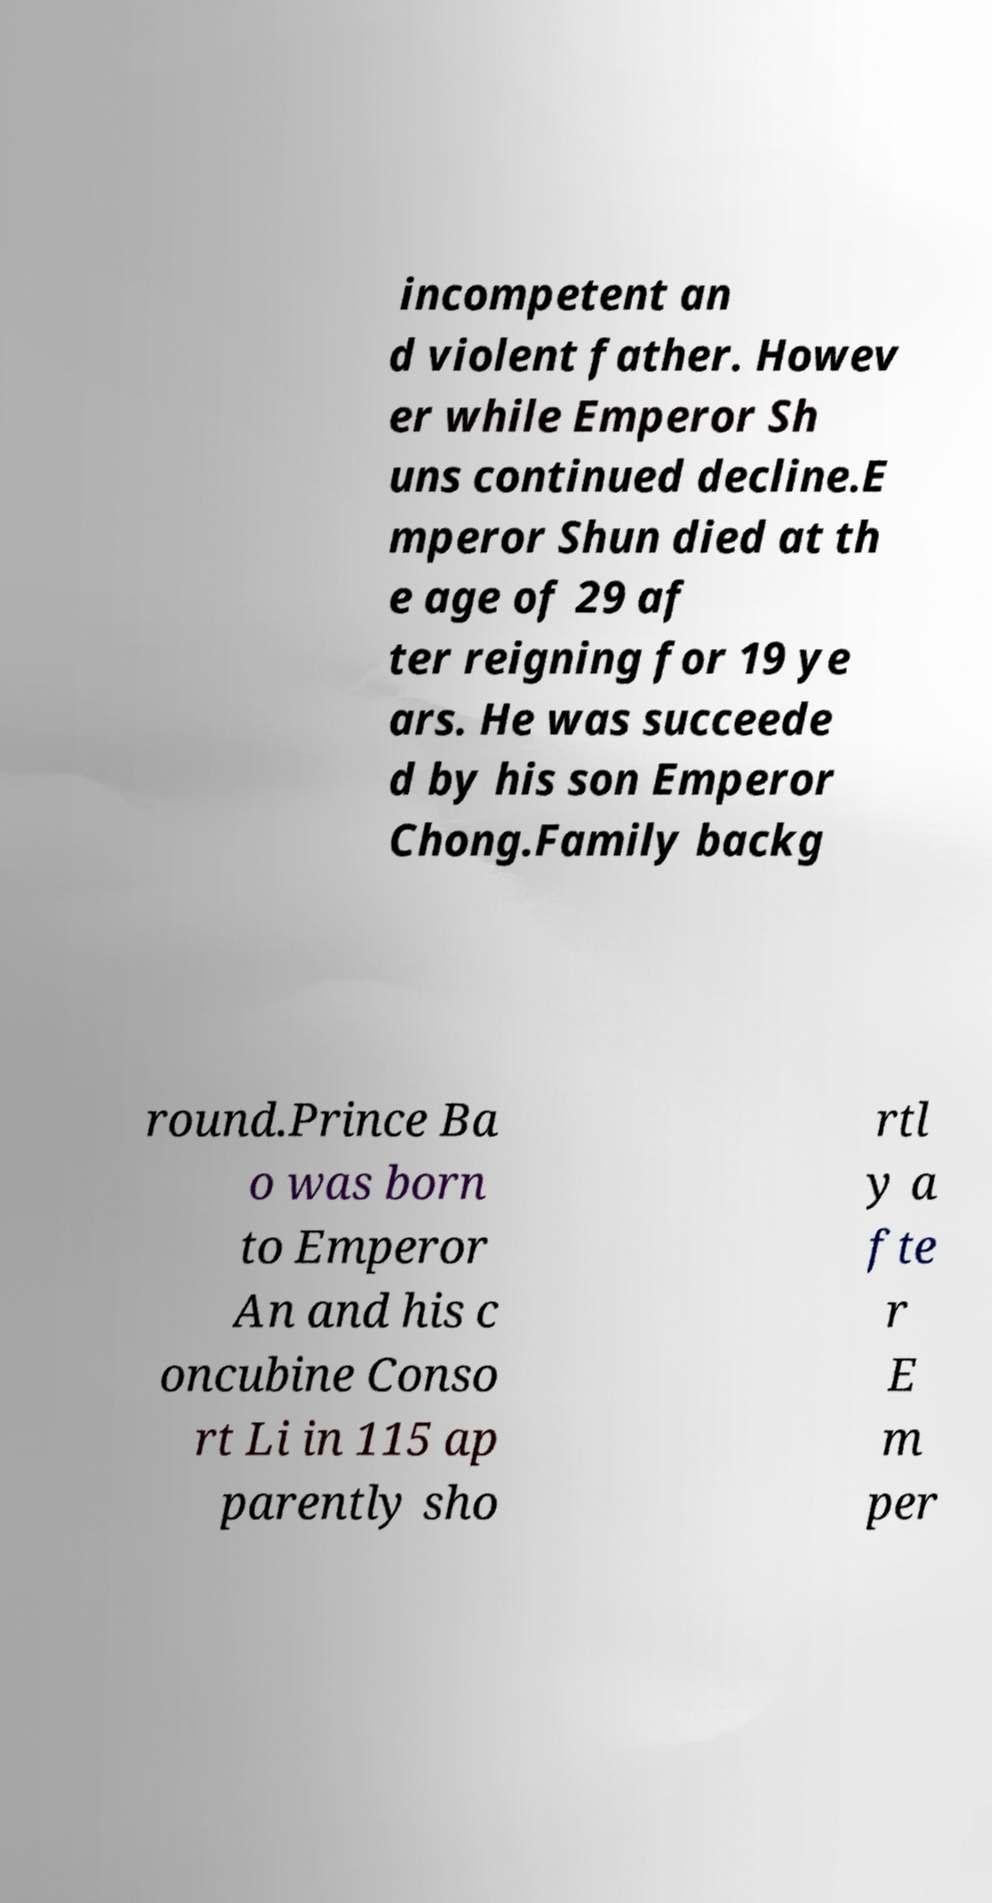Could you extract and type out the text from this image? incompetent an d violent father. Howev er while Emperor Sh uns continued decline.E mperor Shun died at th e age of 29 af ter reigning for 19 ye ars. He was succeede d by his son Emperor Chong.Family backg round.Prince Ba o was born to Emperor An and his c oncubine Conso rt Li in 115 ap parently sho rtl y a fte r E m per 